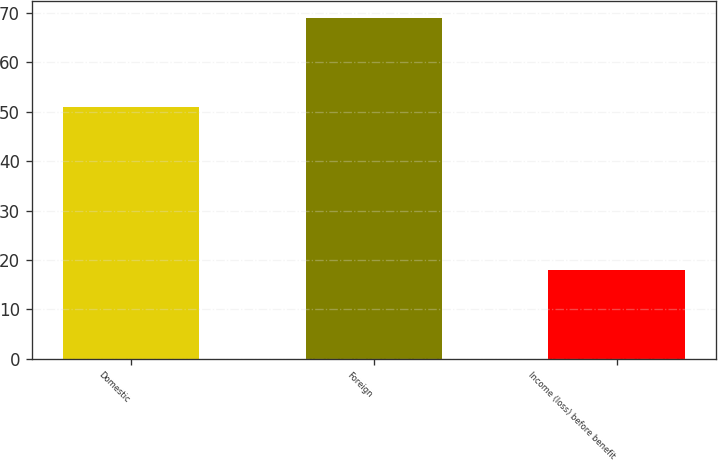Convert chart to OTSL. <chart><loc_0><loc_0><loc_500><loc_500><bar_chart><fcel>Domestic<fcel>Foreign<fcel>Income (loss) before benefit<nl><fcel>51<fcel>69<fcel>18<nl></chart> 